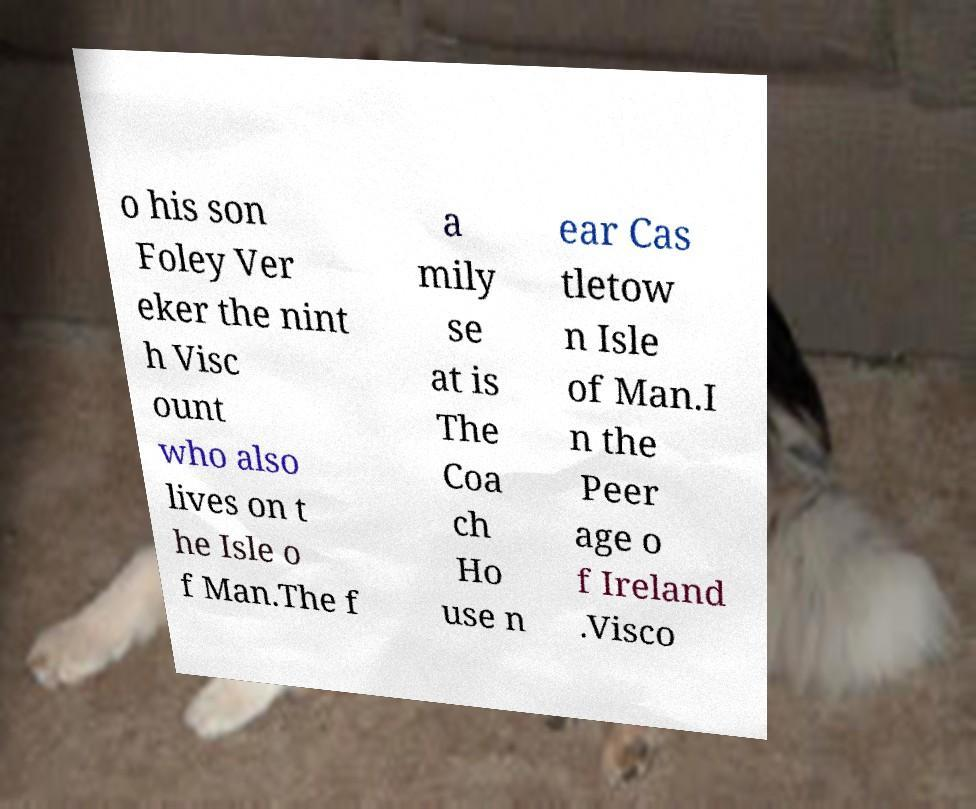Can you read and provide the text displayed in the image?This photo seems to have some interesting text. Can you extract and type it out for me? o his son Foley Ver eker the nint h Visc ount who also lives on t he Isle o f Man.The f a mily se at is The Coa ch Ho use n ear Cas tletow n Isle of Man.I n the Peer age o f Ireland .Visco 